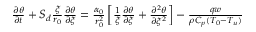<formula> <loc_0><loc_0><loc_500><loc_500>\begin{array} { r } { \frac { \partial \theta } { \partial t } + S _ { d } \frac { \xi } { r _ { 0 } } \frac { \partial \theta } { \partial \xi } = \frac { \alpha _ { 0 } } { r _ { 0 } ^ { 2 } } \left [ \frac { 1 } { \xi } \frac { \partial \theta } { \partial \xi } + \frac { \partial ^ { 2 } \theta } { \partial \xi ^ { 2 } } \right ] - \frac { q w } { \rho C _ { p } ( T _ { 0 } - T _ { u } ) } } \end{array}</formula> 